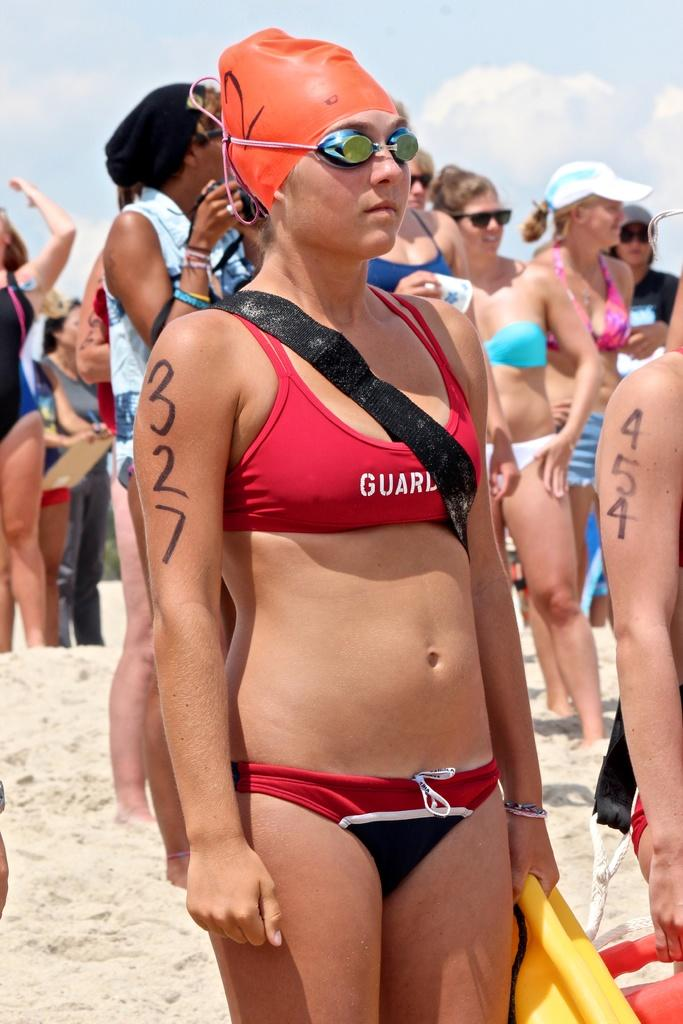<image>
Relay a brief, clear account of the picture shown. Swimmer 327 is relaxing on the beach before her swim race. 